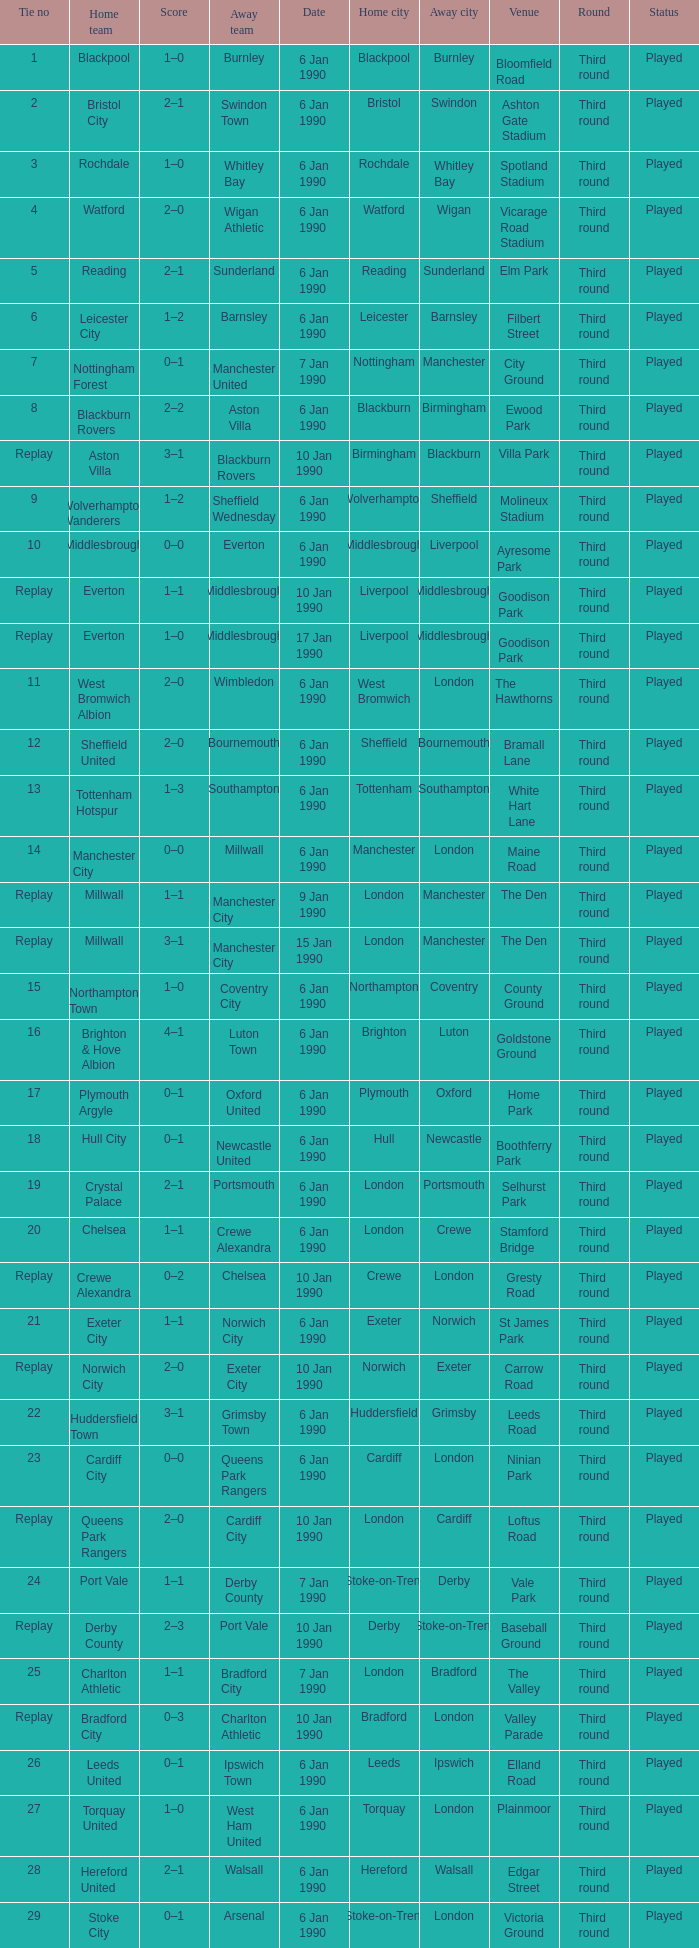What date did home team liverpool play? 9 Jan 1990. 